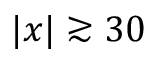<formula> <loc_0><loc_0><loc_500><loc_500>| x | \gtrsim 3 0</formula> 